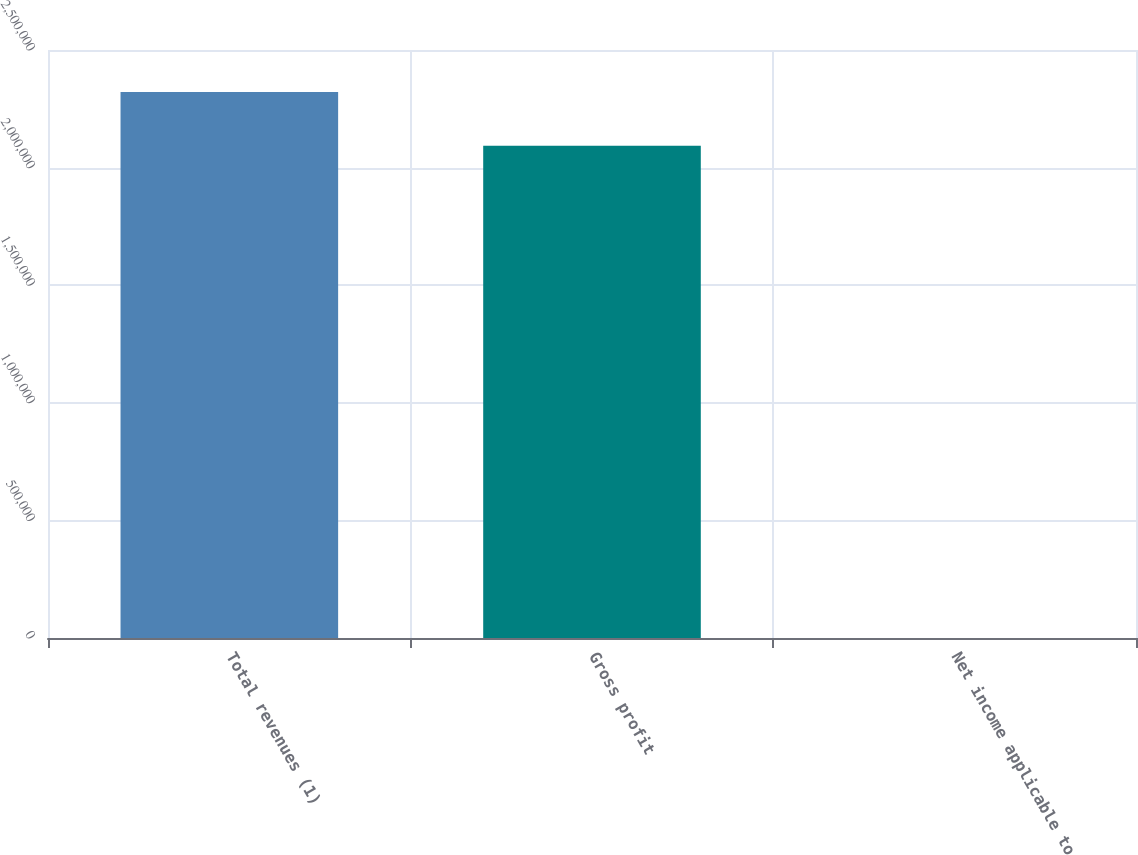<chart> <loc_0><loc_0><loc_500><loc_500><bar_chart><fcel>Total revenues (1)<fcel>Gross profit<fcel>Net income applicable to<nl><fcel>2.32094e+06<fcel>2.09291e+06<fcel>9.94<nl></chart> 